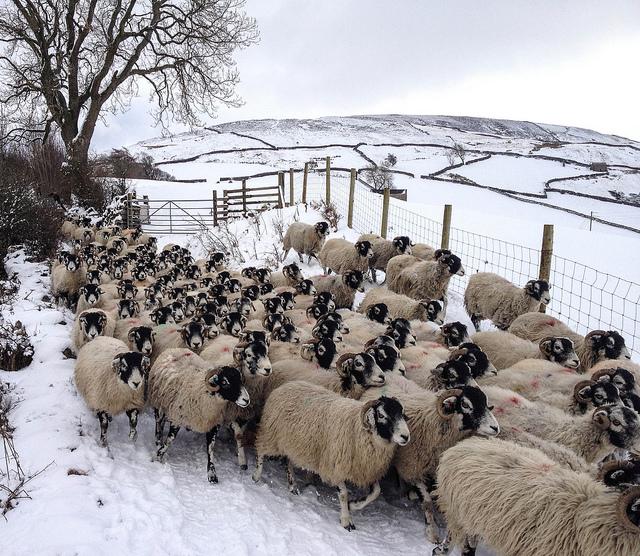What covers the ground?
Answer briefly. Snow. What kind of animals are these?
Concise answer only. Sheep. Who is herding all these sheep?
Answer briefly. Shepherd. 